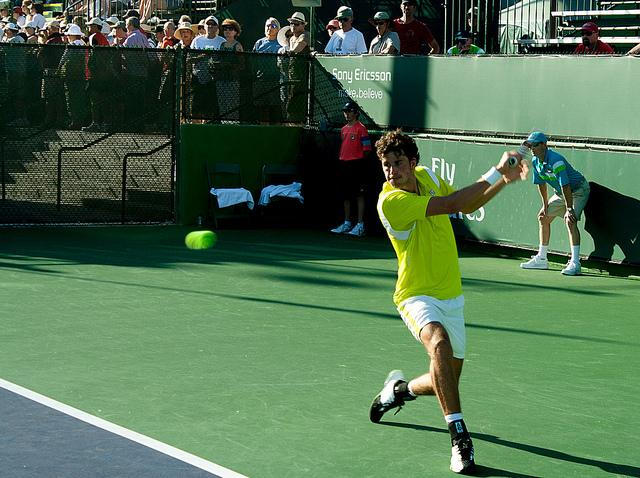Who are the people standing behind the gate? Please explain your reasoning. spectators. There are spectators watching. 